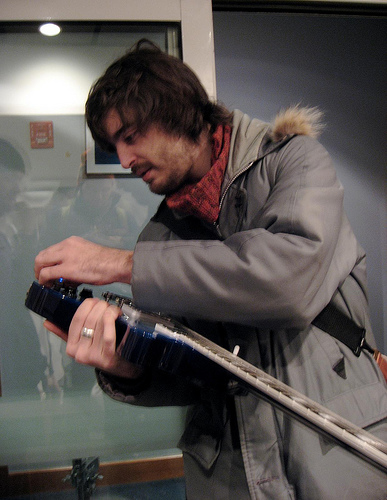<image>
Is there a guitar in front of the winter jacket? Yes. The guitar is positioned in front of the winter jacket, appearing closer to the camera viewpoint. 